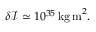Convert formula to latex. <formula><loc_0><loc_0><loc_500><loc_500>\delta \mathcal { I } \simeq 1 0 ^ { 3 5 } \, k g \, m ^ { 2 } .</formula> 